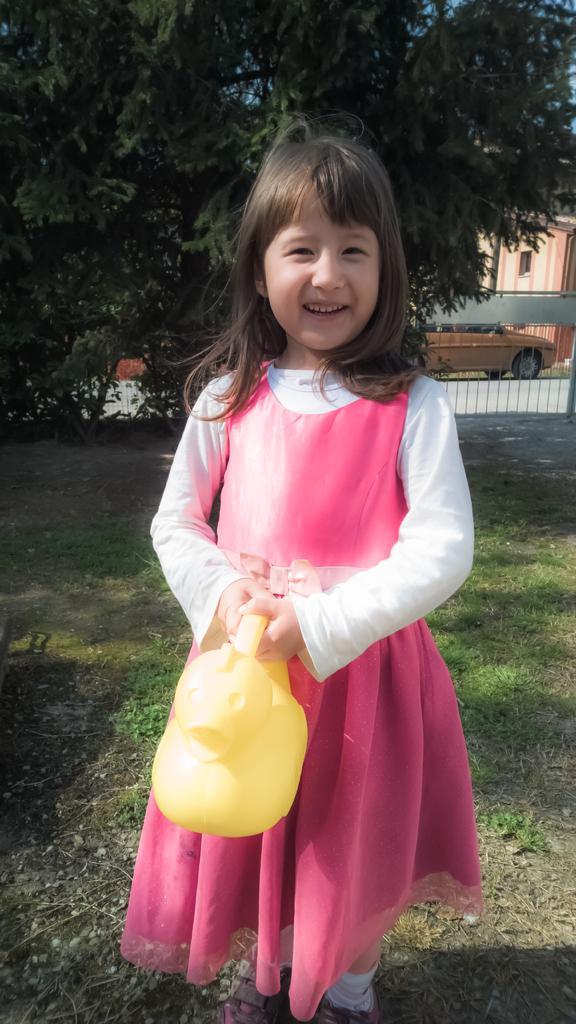Please provide a concise description of this image. In the foreground of this image, there is a girl holding a yellow color object and standing on the grass. In the background, there is a tree, a gate, wall of a building and a vehicle. 